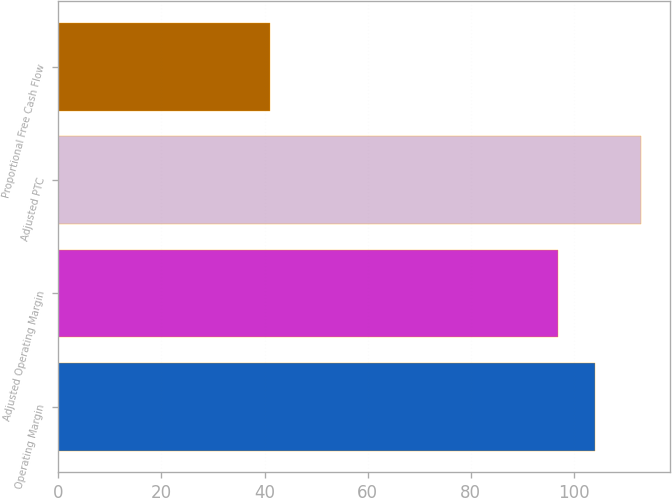<chart> <loc_0><loc_0><loc_500><loc_500><bar_chart><fcel>Operating Margin<fcel>Adjusted Operating Margin<fcel>Adjusted PTC<fcel>Proportional Free Cash Flow<nl><fcel>104.2<fcel>97<fcel>113<fcel>41<nl></chart> 